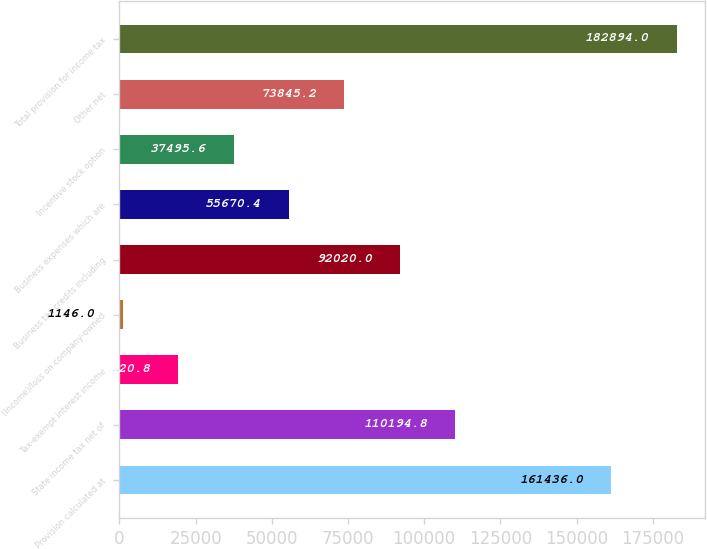<chart> <loc_0><loc_0><loc_500><loc_500><bar_chart><fcel>Provision calculated at<fcel>State income tax net of<fcel>Tax-exempt interest income<fcel>(Income)/loss on company-owned<fcel>Business tax credits including<fcel>Business expenses which are<fcel>Incentive stock option<fcel>Other net<fcel>Total provision for income tax<nl><fcel>161436<fcel>110195<fcel>19320.8<fcel>1146<fcel>92020<fcel>55670.4<fcel>37495.6<fcel>73845.2<fcel>182894<nl></chart> 